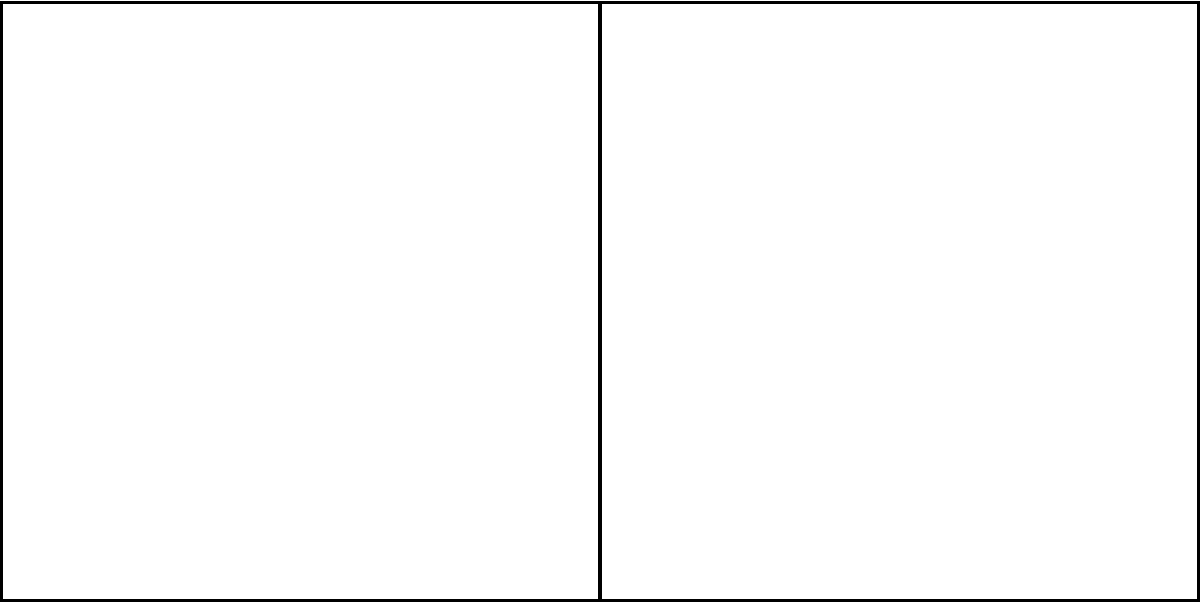A food truck needs to travel from $v_1$ to $v_6$ while minimizing its route overlap with existing restaurants (marked as R). Given the graph where edge weights represent distance in blocks, what is the shortest path that passes by at most one restaurant? To solve this problem, we need to consider all possible paths from $v_1$ to $v_6$ and evaluate which one meets the criteria of passing by at most one restaurant while minimizing the total distance. Let's break it down step-by-step:

1. Identify all possible paths from $v_1$ to $v_6$:
   a) $v_1 - v_2 - v_6$
   b) $v_1 - v_2 - v_5 - v_6$
   c) $v_1 - v_4 - v_5 - v_6$
   d) $v_1 - v_4 - v_3 - v_4 - v_5 - v_6$

2. Evaluate each path:
   a) $v_1 - v_2 - v_6$:
      - Passes by 2 restaurants (at $v_1$ and $v_3$)
      - Total distance: $3 + 2 = 5$ blocks
      - Disqualified for passing by more than one restaurant

   b) $v_1 - v_2 - v_5 - v_6$:
      - Passes by 2 restaurants (at $v_1$ and $v_6$)
      - Total distance: $3 + 4 + 3 = 10$ blocks
      - Disqualified for passing by more than one restaurant

   c) $v_1 - v_4 - v_5 - v_6$:
      - Passes by 1 restaurant (at $v_1$)
      - Total distance: $4 + 2 + 3 = 9$ blocks
      - Qualifies as it passes by only one restaurant

   d) $v_1 - v_4 - v_3 - v_4 - v_5 - v_6$:
      - Passes by 1 restaurant (at $v_1$)
      - Total distance: $4 + 2 + 2 + 2 + 3 = 13$ blocks
      - Qualifies but has a longer distance than path c

3. Compare the qualifying paths:
   Only paths c and d qualify by passing at most one restaurant. Path c has a shorter total distance of 9 blocks compared to path d with 13 blocks.

Therefore, the shortest path that passes by at most one restaurant is $v_1 - v_4 - v_5 - v_6$ with a total distance of 9 blocks.
Answer: $v_1 - v_4 - v_5 - v_6$ 